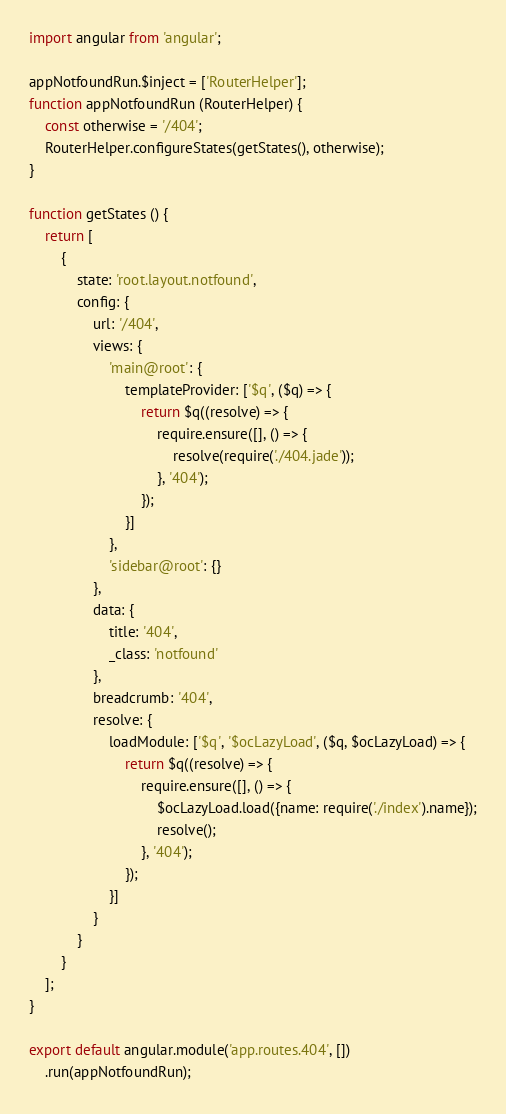Convert code to text. <code><loc_0><loc_0><loc_500><loc_500><_JavaScript_>import angular from 'angular';

appNotfoundRun.$inject = ['RouterHelper'];
function appNotfoundRun (RouterHelper) {
    const otherwise = '/404';
    RouterHelper.configureStates(getStates(), otherwise);
}

function getStates () {
    return [
        {
            state: 'root.layout.notfound',
            config: {
                url: '/404',
                views: {
                    'main@root': {
                        templateProvider: ['$q', ($q) => {
                            return $q((resolve) => {
                                require.ensure([], () => {
                                    resolve(require('./404.jade'));
                                }, '404');
                            });
                        }]
                    },
                    'sidebar@root': {}
                },
                data: {
                    title: '404',
                    _class: 'notfound'
                },
                breadcrumb: '404',
                resolve: {
                    loadModule: ['$q', '$ocLazyLoad', ($q, $ocLazyLoad) => {
                        return $q((resolve) => {
                            require.ensure([], () => {
                                $ocLazyLoad.load({name: require('./index').name});
                                resolve();
                            }, '404');
                        });
                    }]
                }
            }
        }
    ];
}

export default angular.module('app.routes.404', [])
    .run(appNotfoundRun);
</code> 